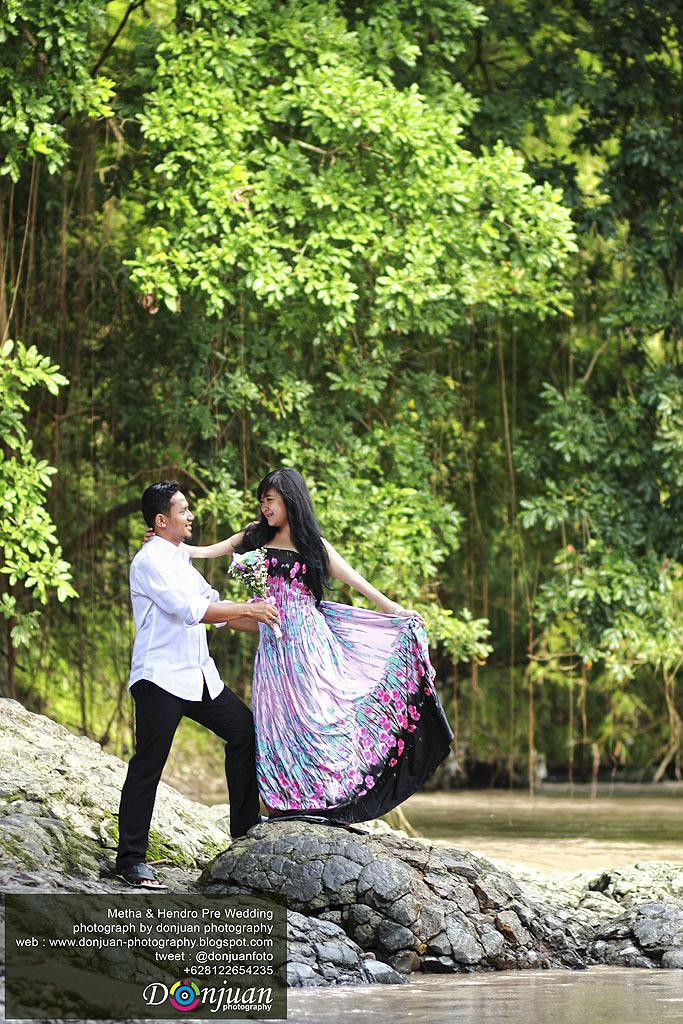Who are the two people in the image? There is a man and a lady standing in the center of the image. What can be seen in the background of the image? There are trees in the background of the image. What is at the bottom of the image? There are rocks and water visible at the bottom of the image. What type of leaf is being used as a surprise prop in the image? There is no leaf or surprise prop present in the image. 